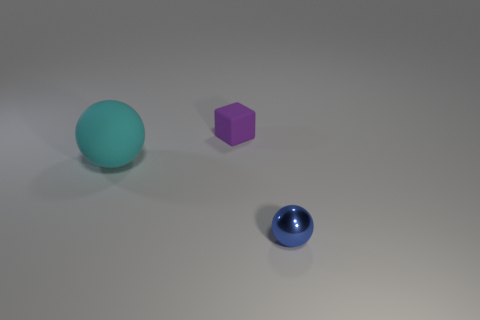Add 1 big cyan balls. How many objects exist? 4 Subtract all blocks. How many objects are left? 2 Subtract all big green spheres. Subtract all purple things. How many objects are left? 2 Add 3 blue metallic balls. How many blue metallic balls are left? 4 Add 3 small rubber objects. How many small rubber objects exist? 4 Subtract 0 green spheres. How many objects are left? 3 